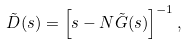<formula> <loc_0><loc_0><loc_500><loc_500>\tilde { D } ( s ) = \left [ s - N \tilde { G } ( s ) \right ] ^ { - 1 } ,</formula> 